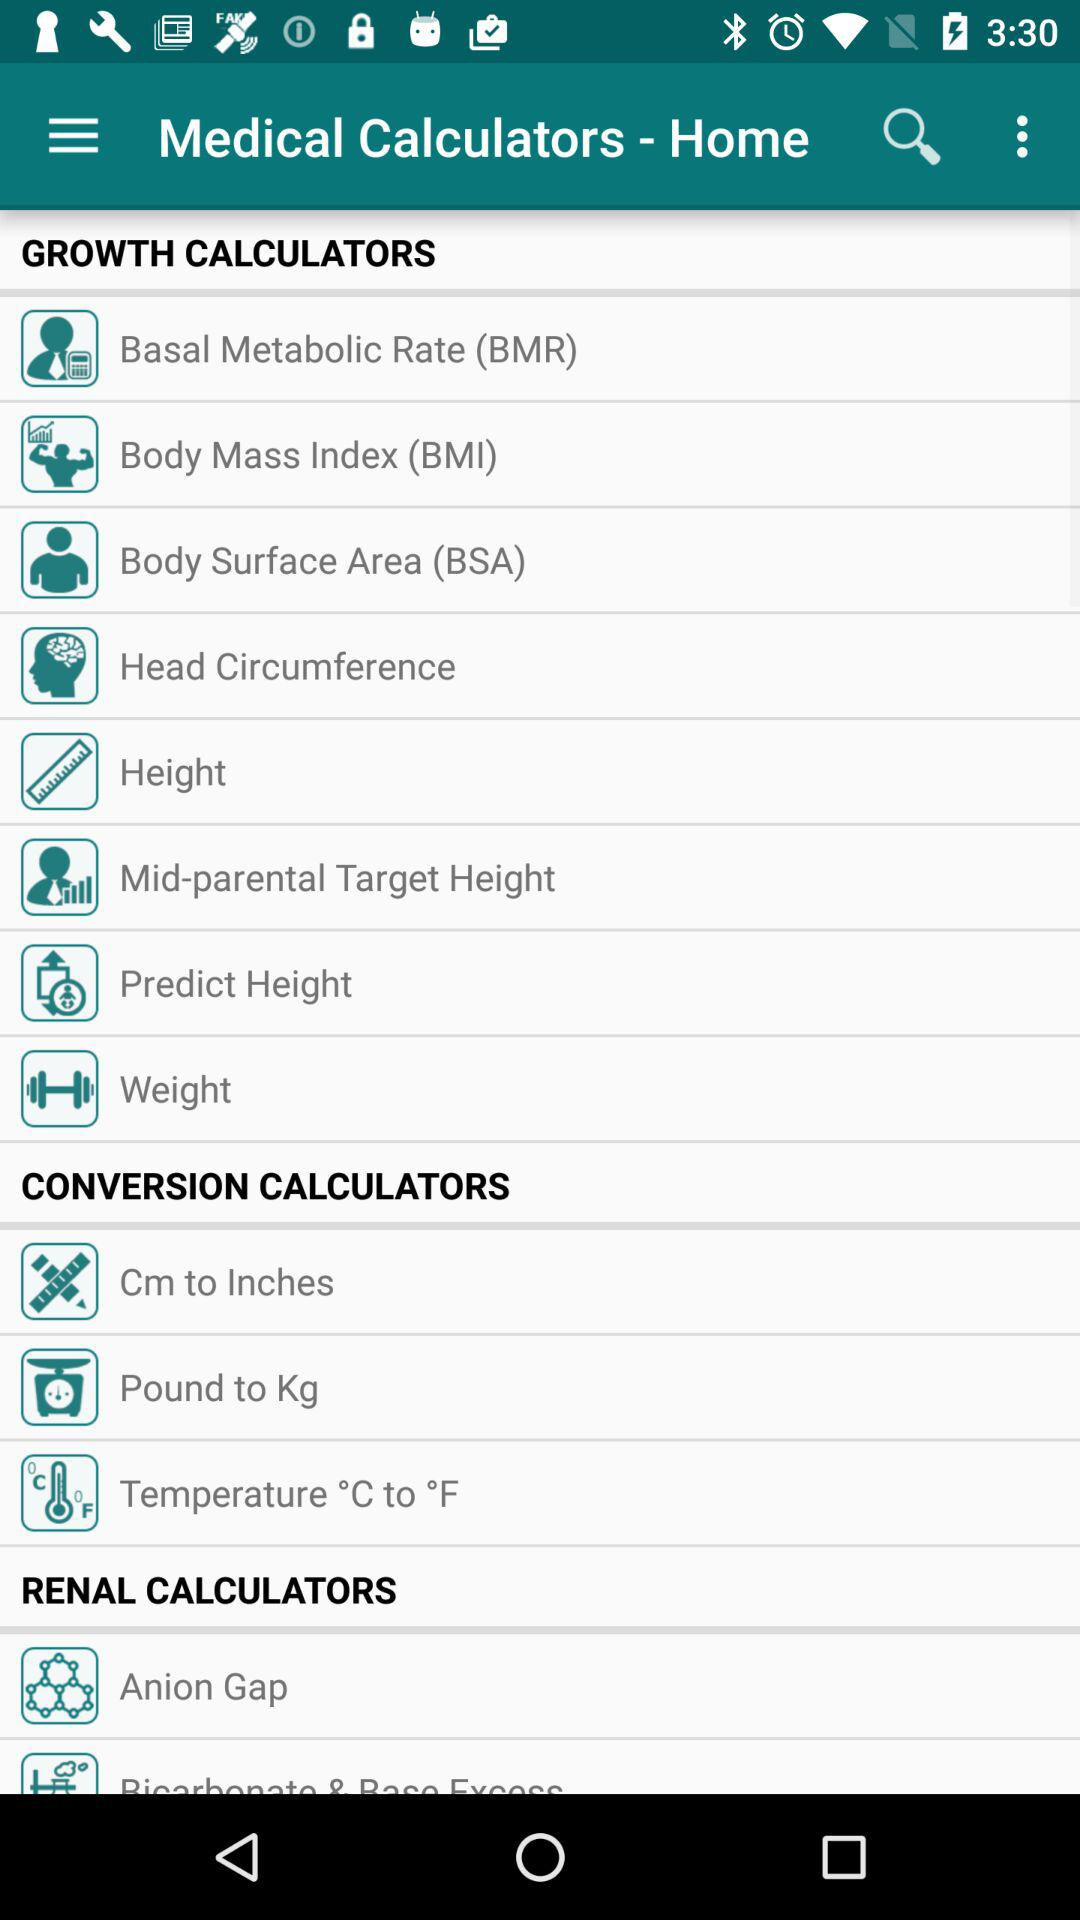What are the different available options in the "GROWTH CALCULATORS"? The different available options in the "GROWTH CALCULATORS" are "Basal Metabolic Rate (BMR)", "Body Mass Index (BMI)", "Body Surface Area (BSA)", "Head Circumference", "Height", "Mid-parental Target Height", "Predict Height" and "Weight". 